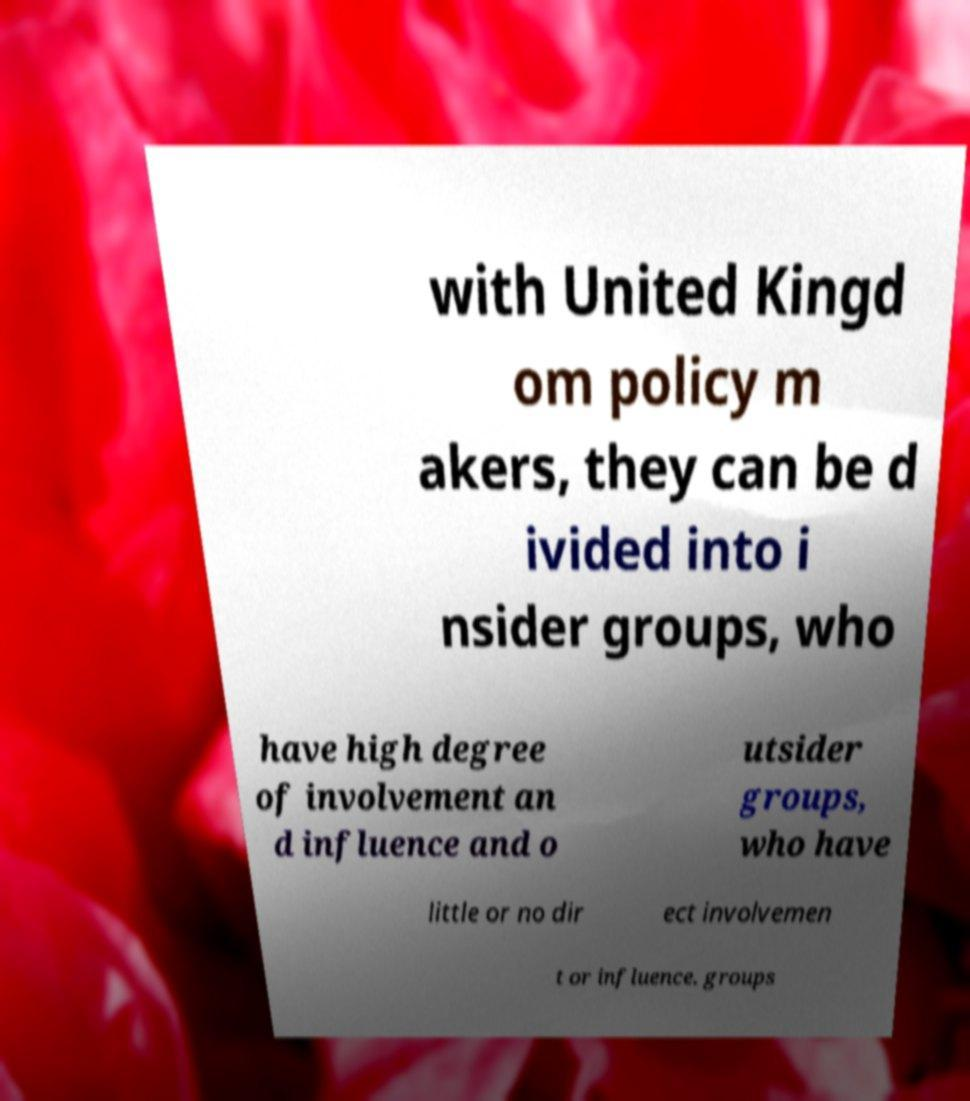Please identify and transcribe the text found in this image. with United Kingd om policy m akers, they can be d ivided into i nsider groups, who have high degree of involvement an d influence and o utsider groups, who have little or no dir ect involvemen t or influence. groups 